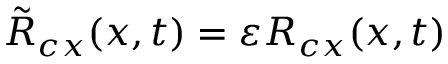<formula> <loc_0><loc_0><loc_500><loc_500>\tilde { R } _ { c x } ( x , t ) = \varepsilon R _ { c x } ( x , t )</formula> 